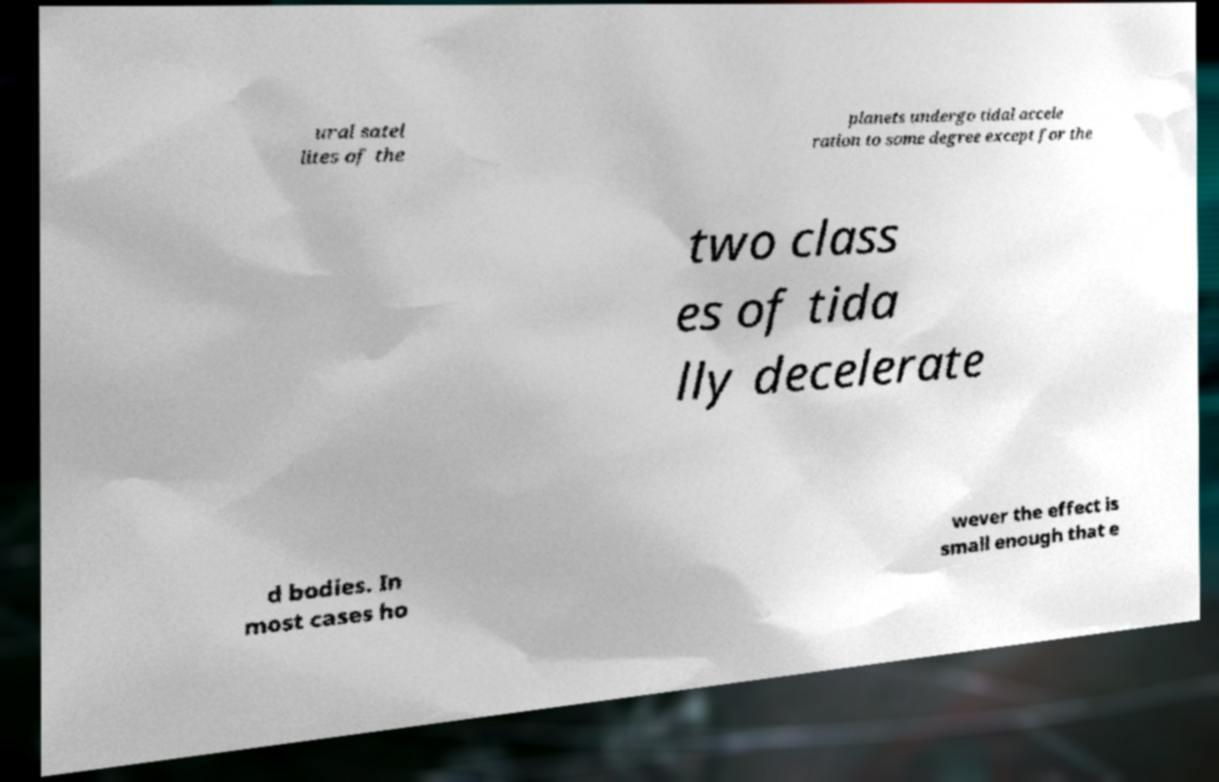Can you read and provide the text displayed in the image?This photo seems to have some interesting text. Can you extract and type it out for me? ural satel lites of the planets undergo tidal accele ration to some degree except for the two class es of tida lly decelerate d bodies. In most cases ho wever the effect is small enough that e 